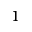<formula> <loc_0><loc_0><loc_500><loc_500>^ { 1 }</formula> 